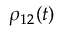<formula> <loc_0><loc_0><loc_500><loc_500>\rho _ { 1 2 } ( t )</formula> 